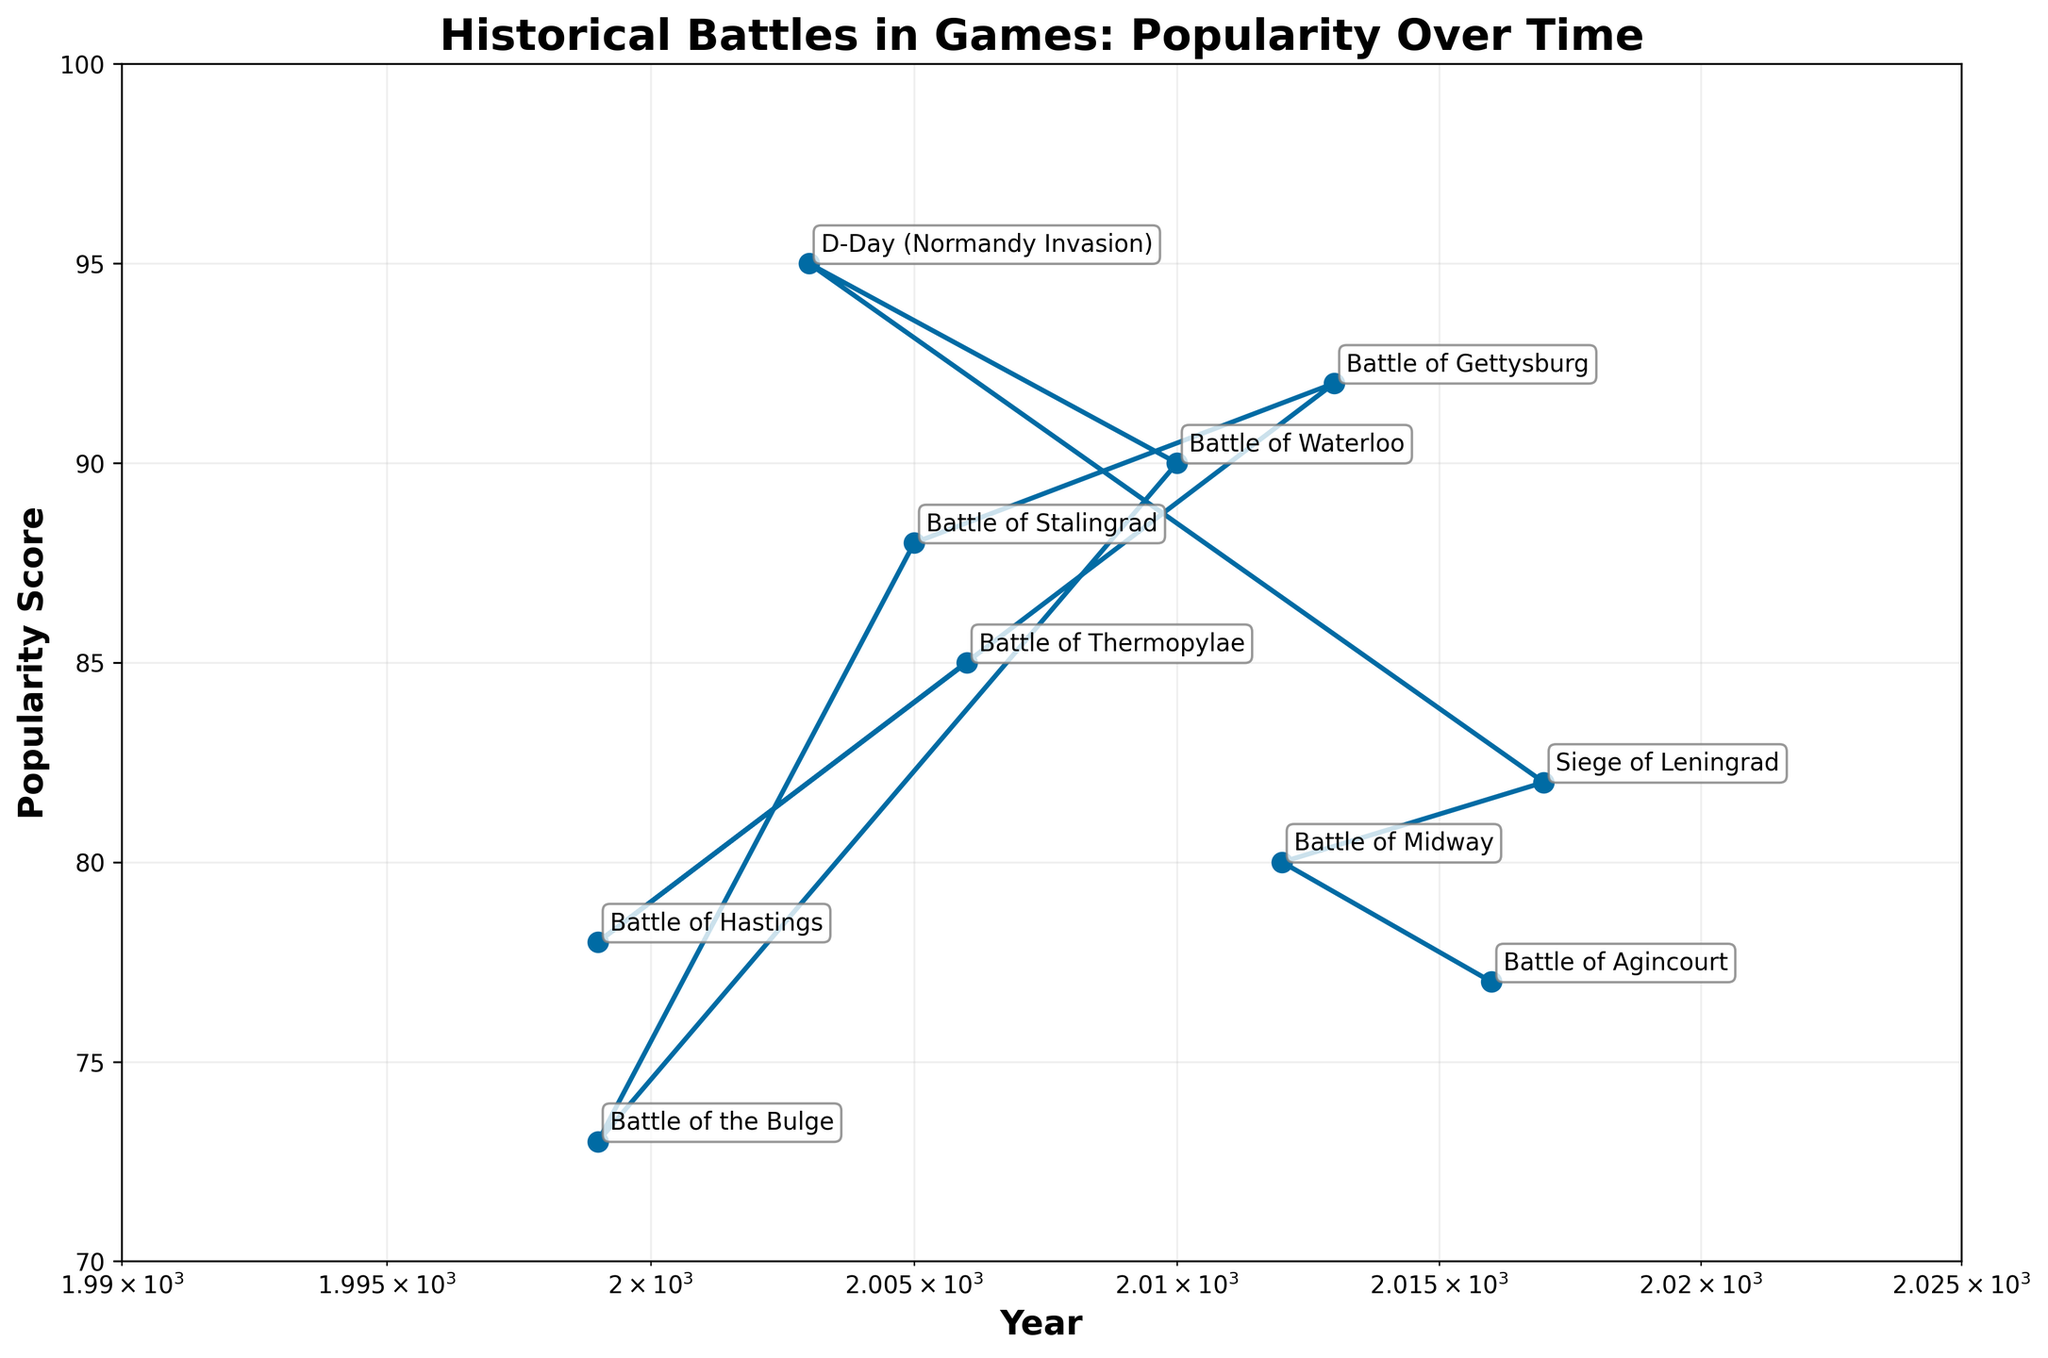What is the title of the plot? The title is located at the top of the plot and describes the general content of the figure.
Answer: Historical Battles in Games: Popularity Over Time What years does the x-axis cover in this plot? The x-axis spans from the year 1990 to 2025 based on the axis limits provided in the figure.
Answer: 1990 to 2025 How many historical battles are represented in the plot? Each datapoint on the plot corresponds to a historical battle, and there are 10 markers visible.
Answer: 10 Which battle has the highest popularity score and what is the score? The highest marker on the y-axis represents the battle with the highest popularity score, identified as D-Day (Normandy Invasion) with a score of 95.
Answer: D-Day (Normandy Invasion), 95 What is the general trend of popularity scores over time? By observing the line plot, the trend shows that popularity scores have varied over the years without a clear upward or downward trend.
Answer: No clear trend Which year saw the highest number of highly rated (90+) games? To determine this, count the number of markers above 90 in different years. The year 2010 has the highest count with Waterloo and Gettysburg games both rated above 90.
Answer: 2010 What is the difference in popularity score between the game released in 1999 and the one in 2017? The popularity score for the 1999 game is 73 (Battle of the Bulge), and for 2017 it is 82 (Siege of Leningrad). Subtract the 1999 score from the 2017 score to get the difference. 82 - 73 = 9.
Answer: 9 How many games have a popularity score of 80 or above? Count the number of markers that lie on or above the 80 on the y-axis. There are 8 such markers.
Answer: 8 Which battle represented in the plot has the lowest popularity score? The lowest marker on the y-axis corresponds to the Battle of the Bulge with a score of 73.
Answer: Battle of the Bulge Which two games released closest to each other in time have the largest difference in popularity score? Identify the years with the smallest difference, then compare their popularity scores. The closest are Battle of Midway (2012, score: 80) and Battle of Gettysburg (2013, score: 92). Difference is 92 - 80 = 12.
Answer: Battle of Midway and Battle of Gettysburg, 12 